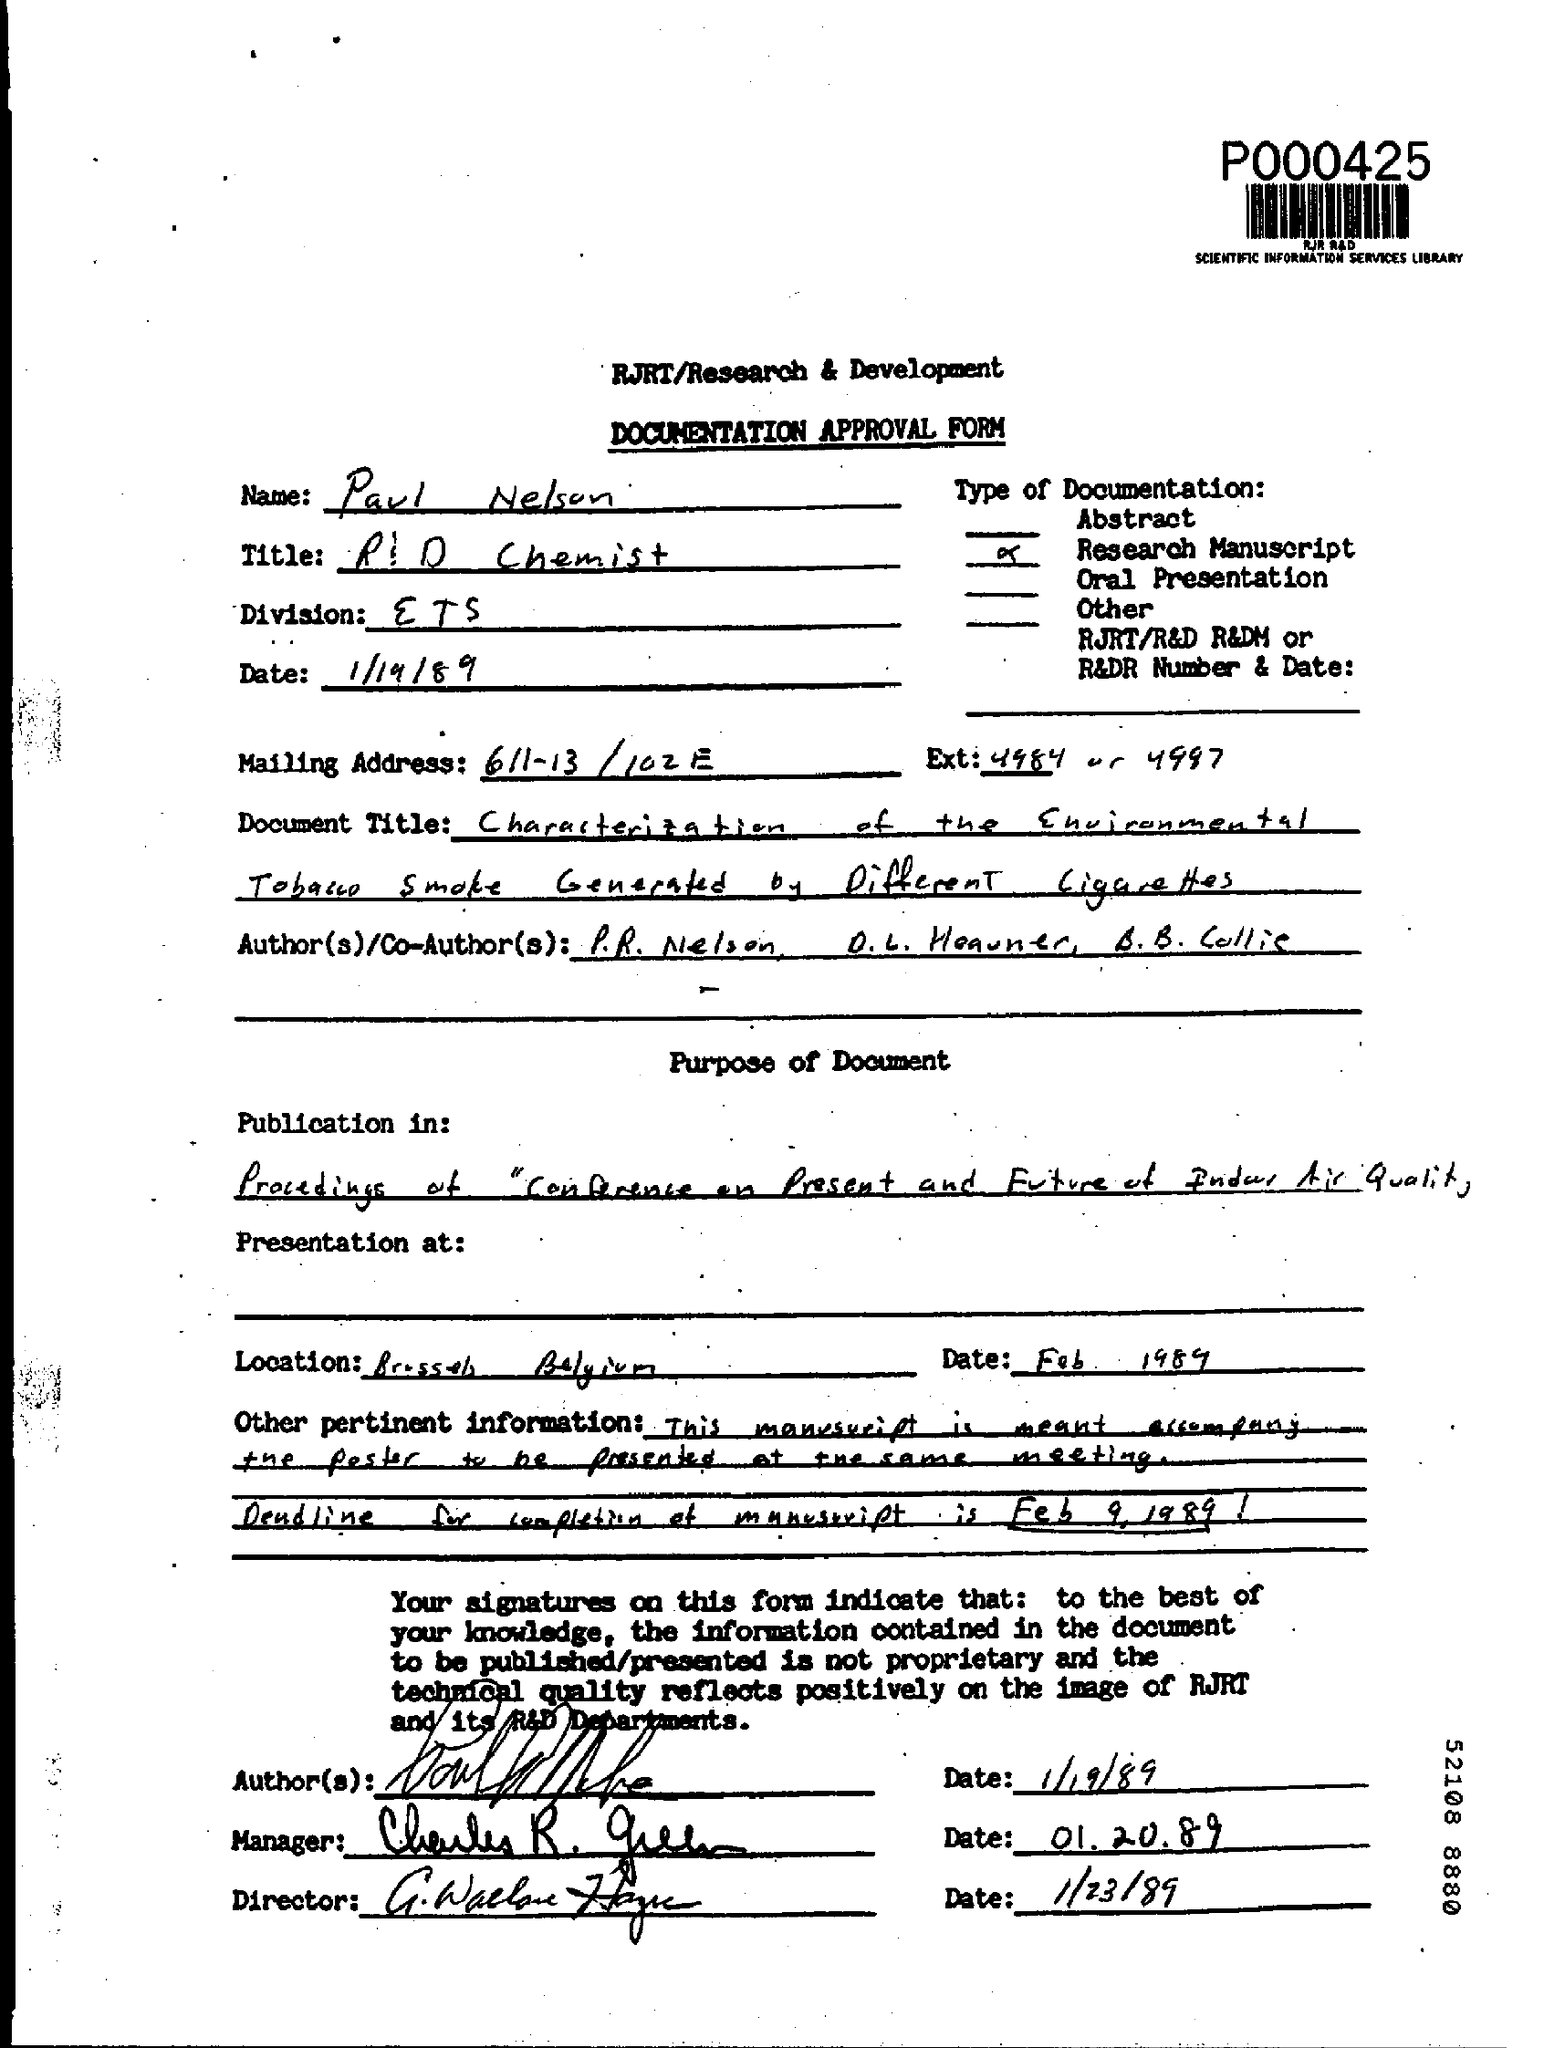What is the date mentioned in the top of the document ?
Give a very brief answer. 1/19/89. What is written in the Division field ?
Offer a very short reply. ETS. 